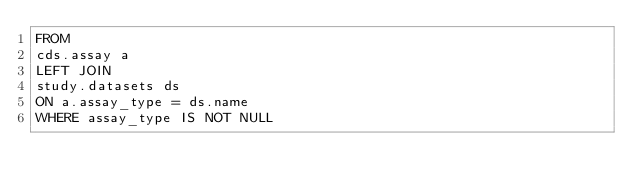Convert code to text. <code><loc_0><loc_0><loc_500><loc_500><_SQL_>FROM
cds.assay a
LEFT JOIN
study.datasets ds
ON a.assay_type = ds.name
WHERE assay_type IS NOT NULL</code> 